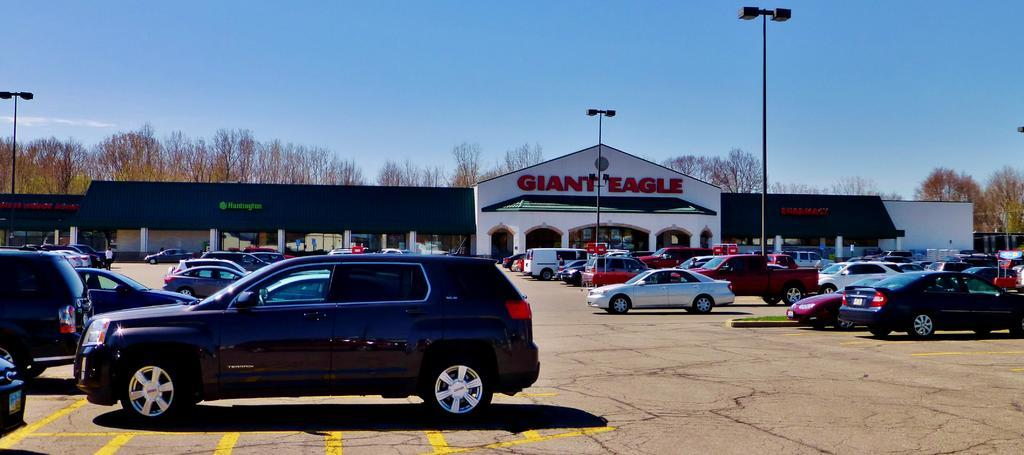What can be seen on the ground in the image? There are vehicles parked on the ground in the image. What structures are present in the image? There are light poles and buildings with text in the image. What type of vegetation is visible in the background of the image? There are trees in the background of the image. What part of the natural environment is visible in the image? The sky is visible in the background of the image. How many clocks are hanging from the light poles in the image? There are no clocks visible on the light poles in the image. What design is featured on the buildings in the image? The provided facts do not mention any specific design on the buildings in the image. 